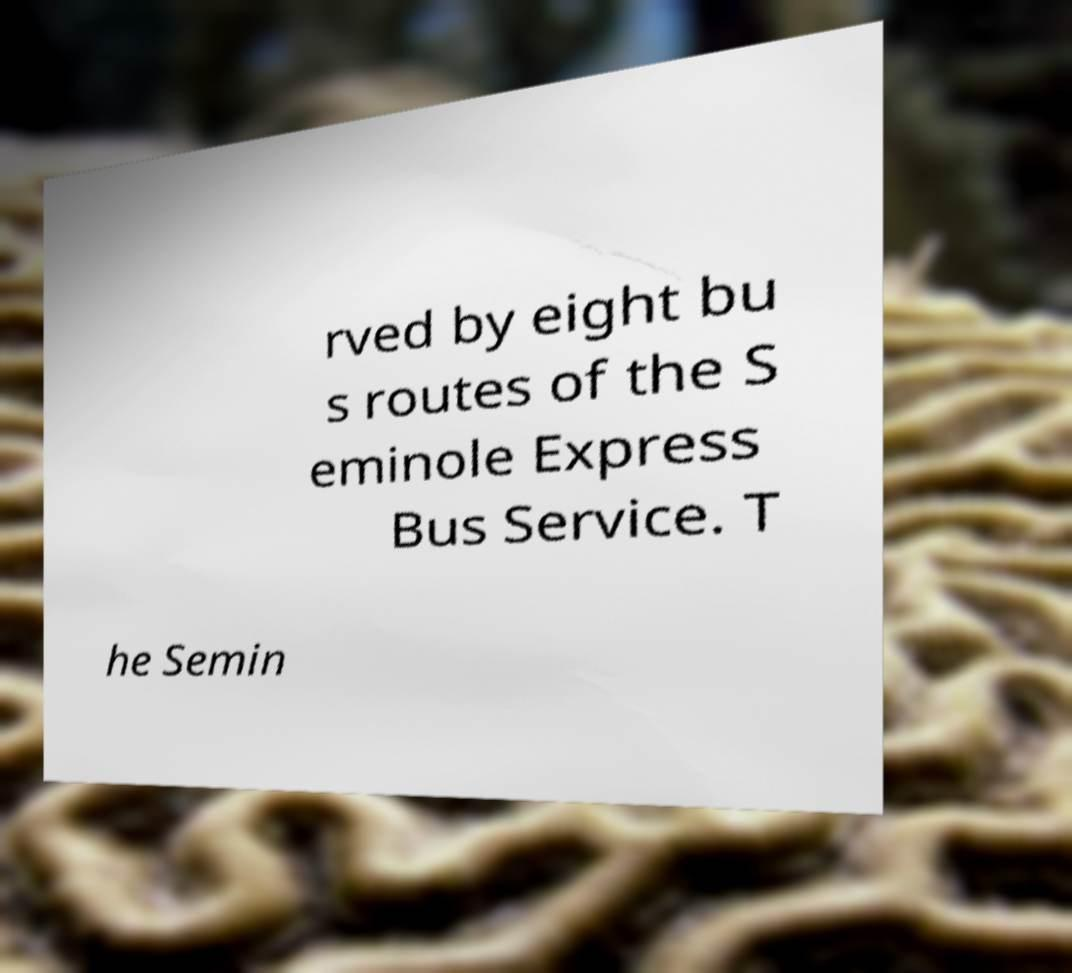Can you read and provide the text displayed in the image?This photo seems to have some interesting text. Can you extract and type it out for me? rved by eight bu s routes of the S eminole Express Bus Service. T he Semin 